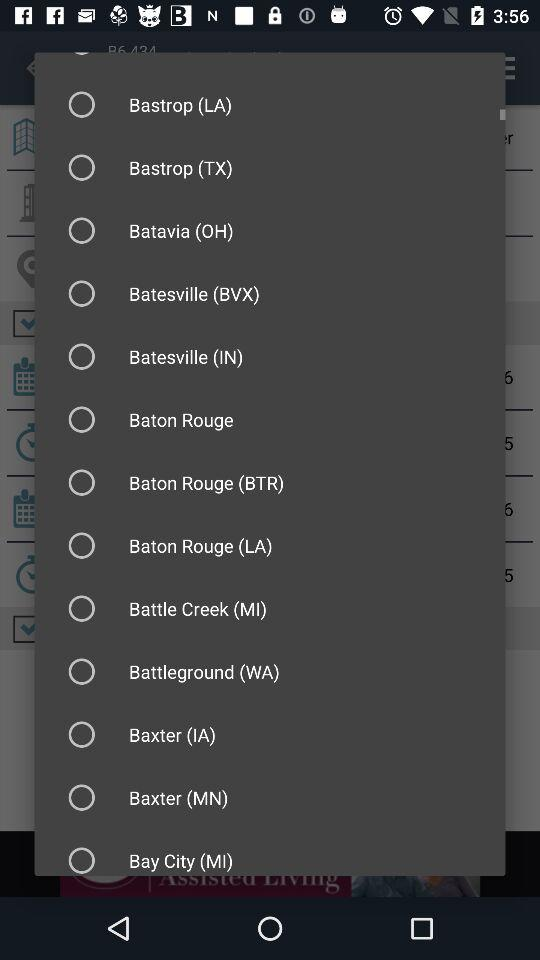What account can I use to share? You can share with Facebook. 